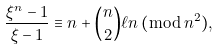<formula> <loc_0><loc_0><loc_500><loc_500>\frac { \xi ^ { n } - 1 } { \xi - 1 } \equiv n + \binom { n } { 2 } \ell n \, ( \bmod { \, n ^ { 2 } } ) ,</formula> 